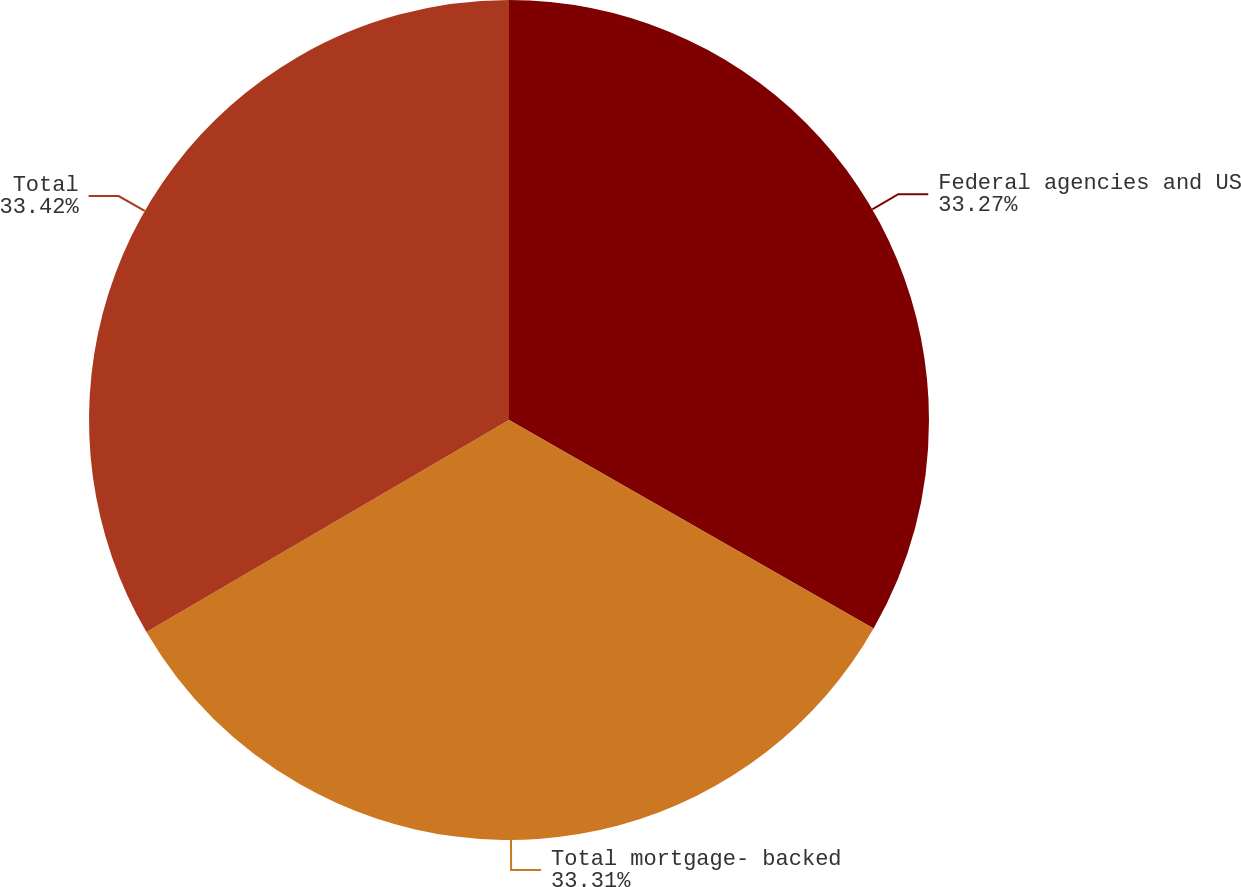Convert chart to OTSL. <chart><loc_0><loc_0><loc_500><loc_500><pie_chart><fcel>Federal agencies and US<fcel>Total mortgage- backed<fcel>Total<nl><fcel>33.27%<fcel>33.31%<fcel>33.42%<nl></chart> 